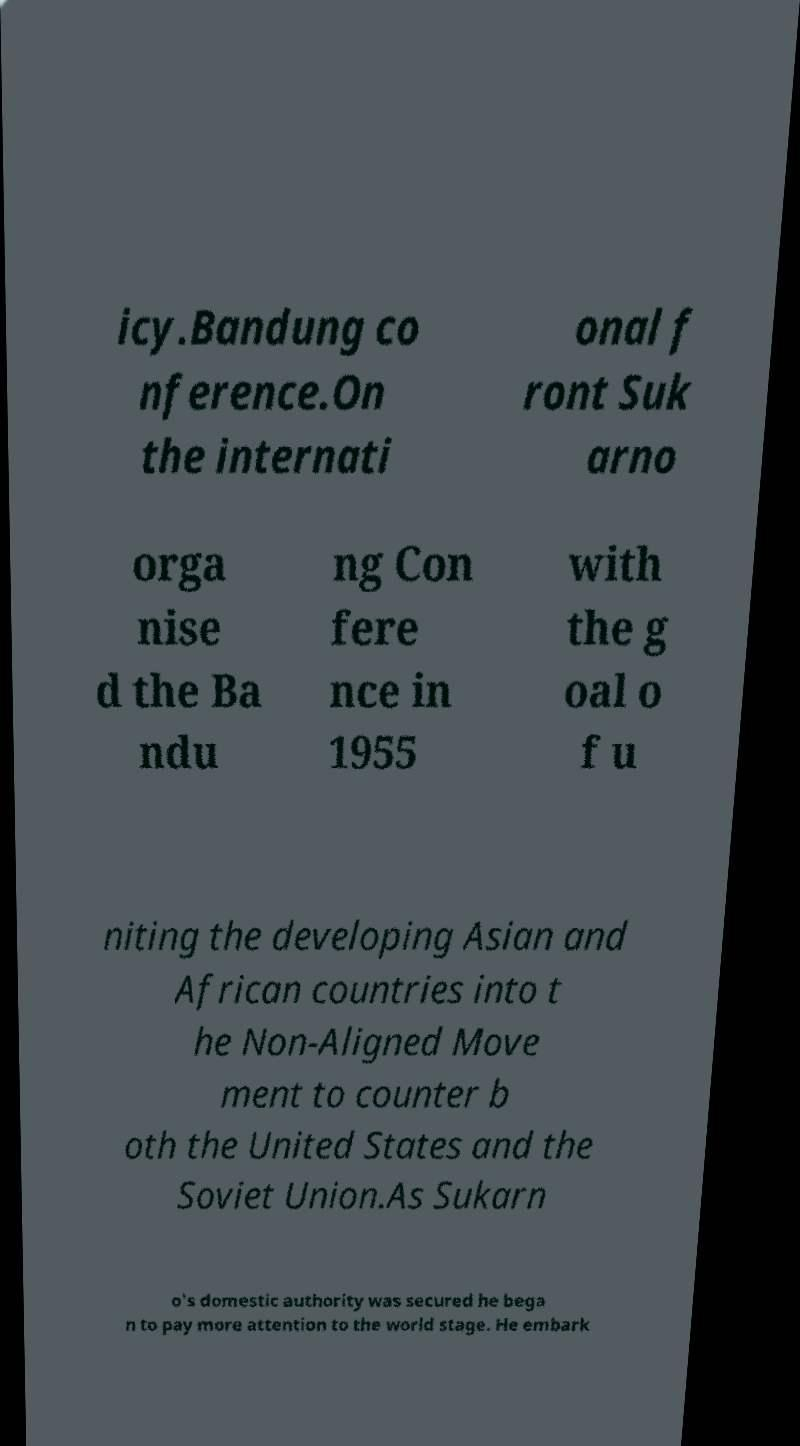Please read and relay the text visible in this image. What does it say? icy.Bandung co nference.On the internati onal f ront Suk arno orga nise d the Ba ndu ng Con fere nce in 1955 with the g oal o f u niting the developing Asian and African countries into t he Non-Aligned Move ment to counter b oth the United States and the Soviet Union.As Sukarn o's domestic authority was secured he bega n to pay more attention to the world stage. He embark 